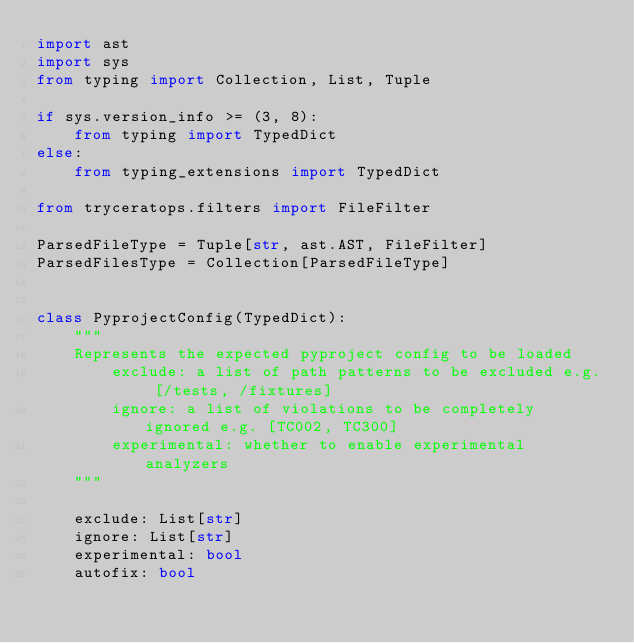<code> <loc_0><loc_0><loc_500><loc_500><_Python_>import ast
import sys
from typing import Collection, List, Tuple

if sys.version_info >= (3, 8):
    from typing import TypedDict
else:
    from typing_extensions import TypedDict

from tryceratops.filters import FileFilter

ParsedFileType = Tuple[str, ast.AST, FileFilter]
ParsedFilesType = Collection[ParsedFileType]


class PyprojectConfig(TypedDict):
    """
    Represents the expected pyproject config to be loaded
        exclude: a list of path patterns to be excluded e.g. [/tests, /fixtures]
        ignore: a list of violations to be completely ignored e.g. [TC002, TC300]
        experimental: whether to enable experimental analyzers
    """

    exclude: List[str]
    ignore: List[str]
    experimental: bool
    autofix: bool
</code> 